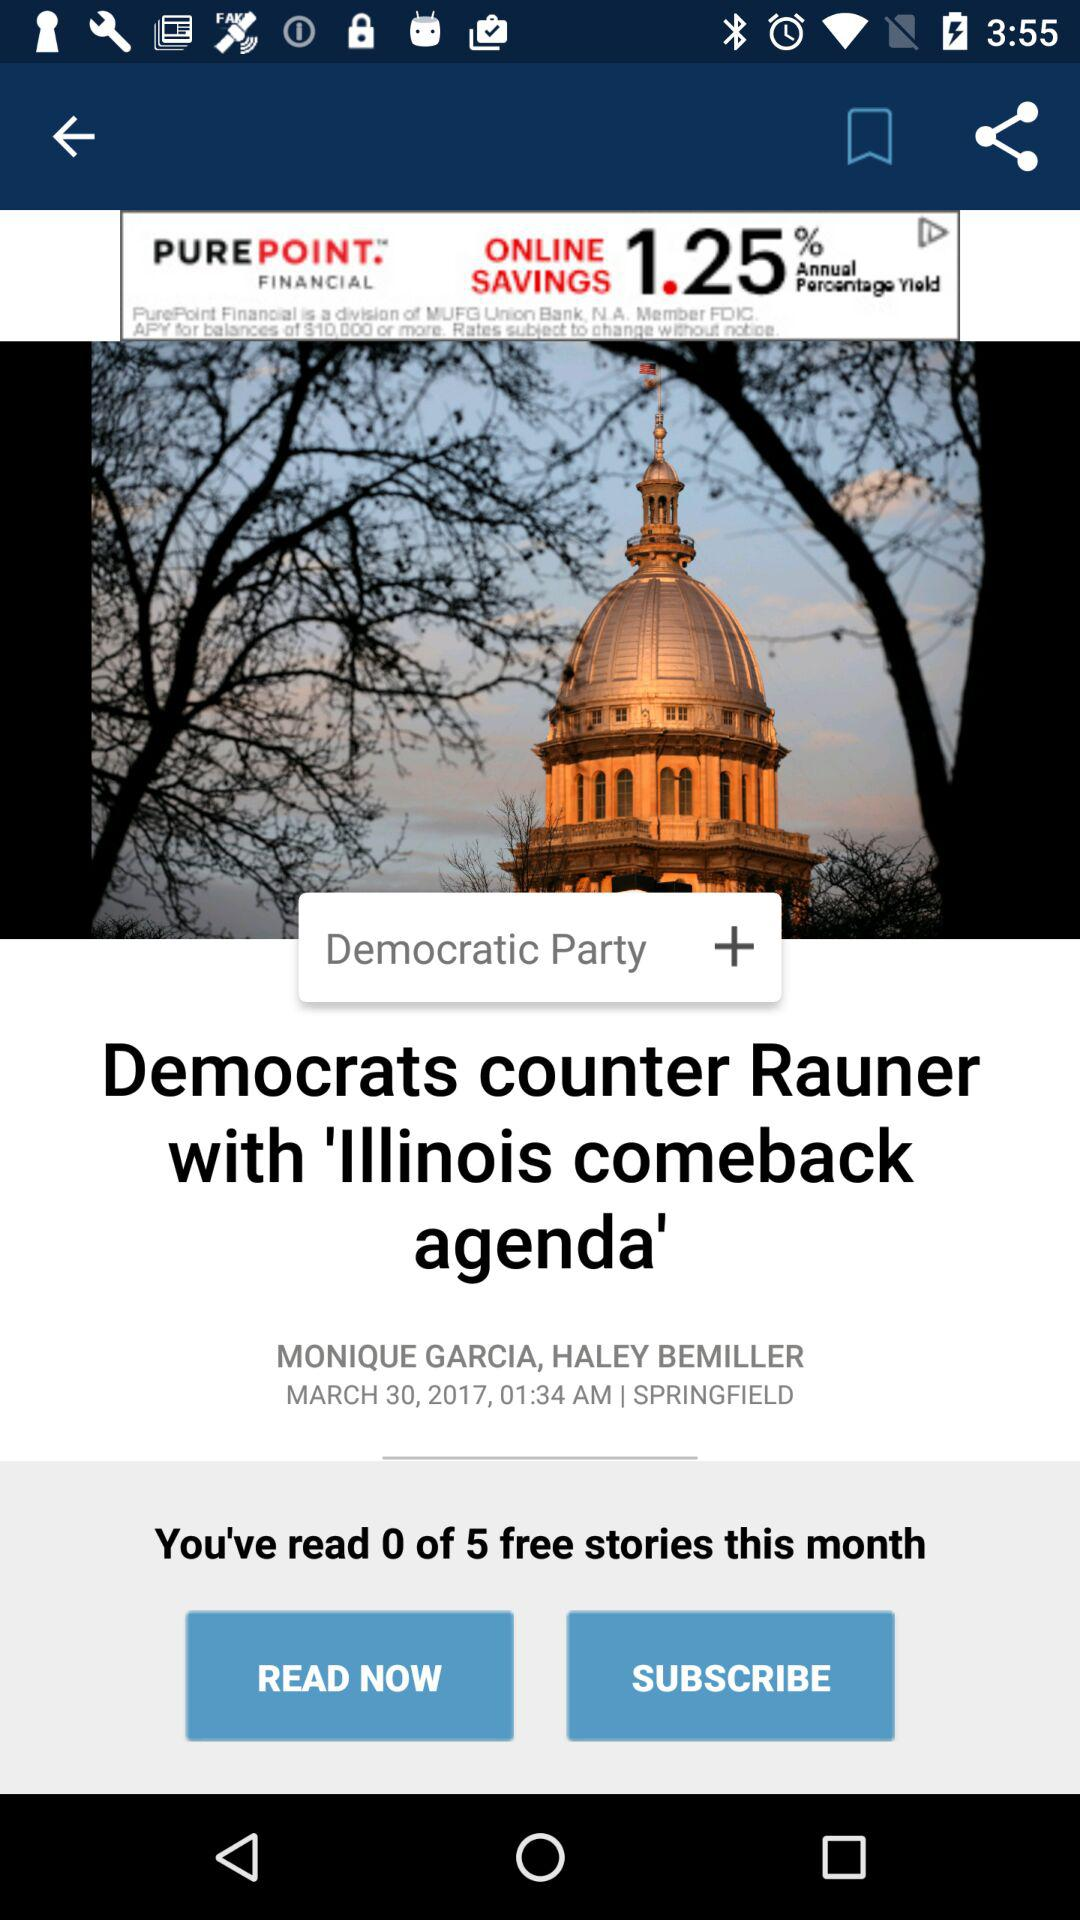How many stories have I read this month?
Answer the question using a single word or phrase. 0 